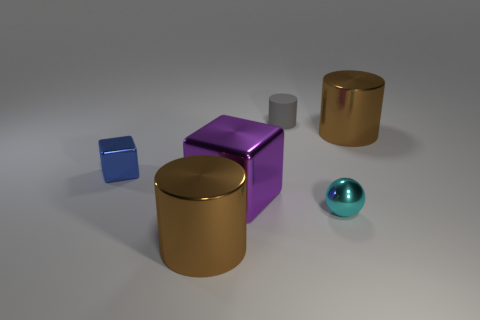How would you describe the lighting of this scene? The lighting in the scene is soft and diffused, coming from above and creating gentle shadows under the objects, which hints at an indoor setting possibly with overhead ambient lighting. 